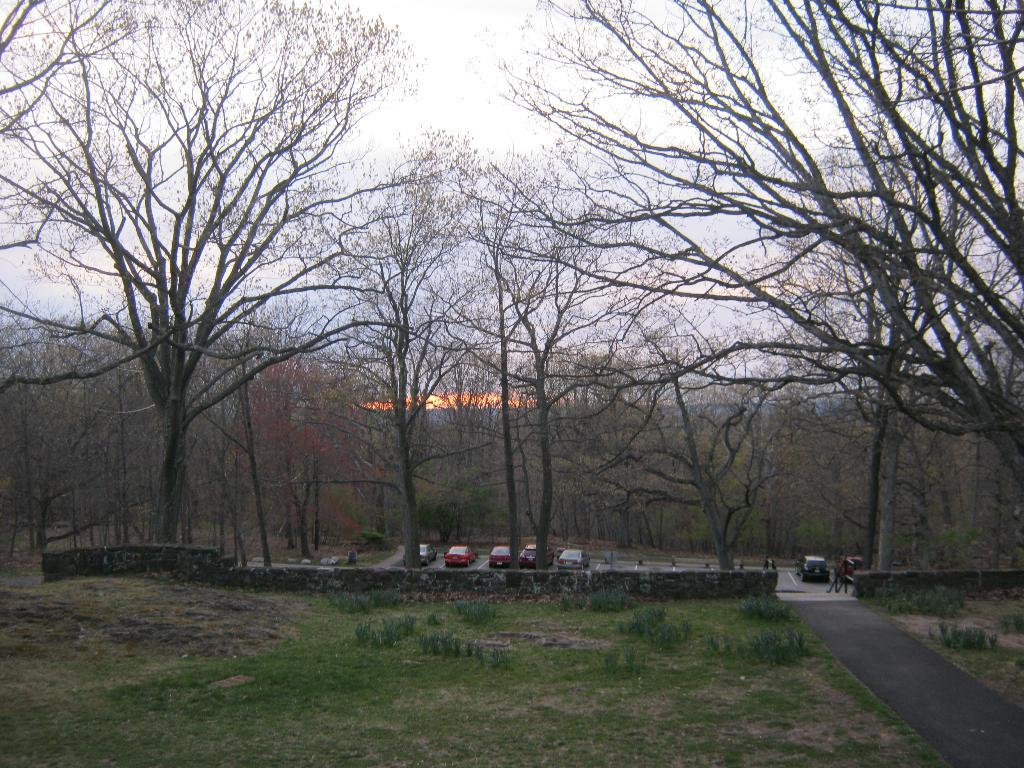What types of objects can be seen on the road in the image? There are vehicles on the road in the image. What else can be seen in the image besides the vehicles? There are trees, grass, plants, and the sky visible in the image. How much payment is required to enter the quiet area in the image? There is no mention of a quiet area or payment in the image; it features vehicles on the road with trees, grass, plants, and the sky. 